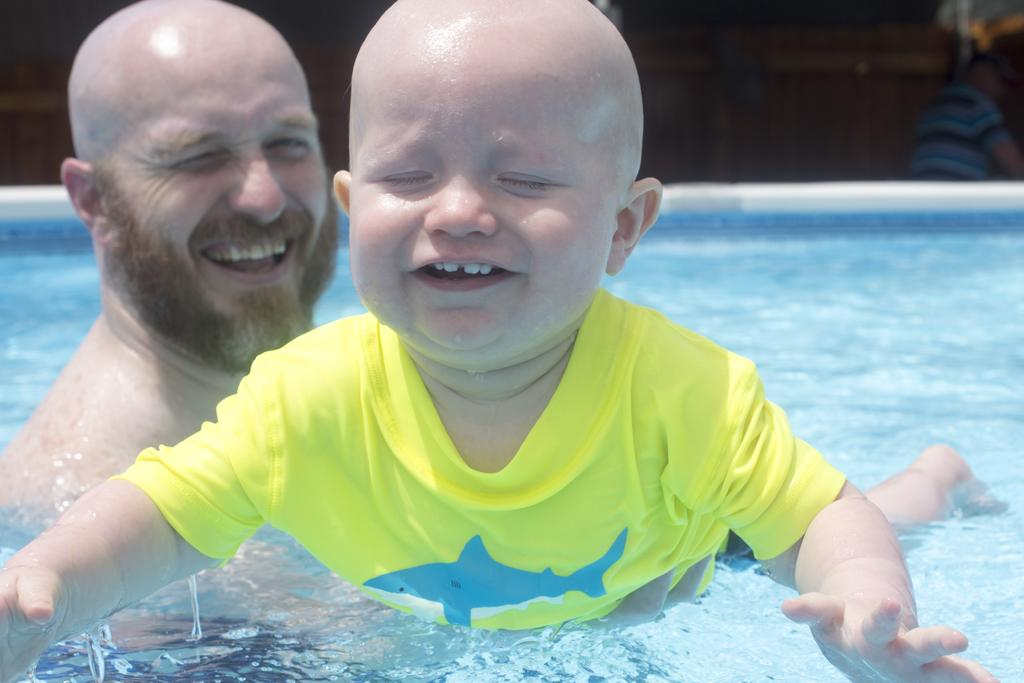How many people are in the swimming pool in the image? There are two persons in the swimming pool. What is the location of the third person in relation to the swimming pool? The third person is behind the swimming pool. What shape is the sign that the person behind the swimming pool is holding? There is no sign present in the image, so it is not possible to determine its shape. 